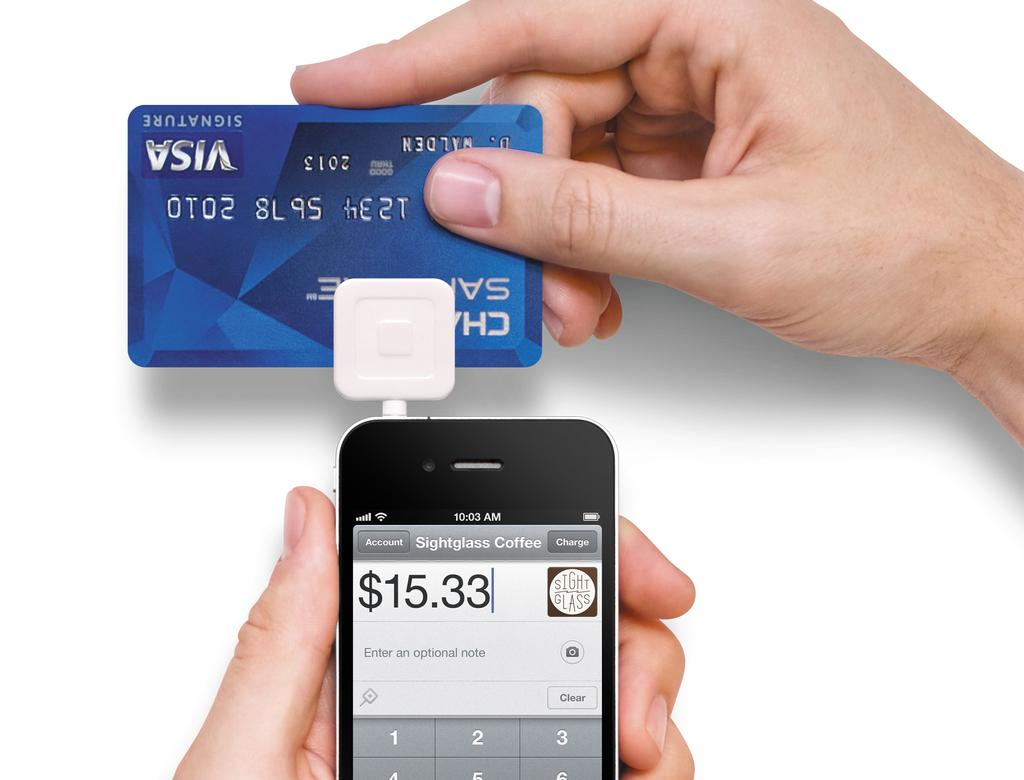<image>
Write a terse but informative summary of the picture. A phone and a VISA card in blue. 